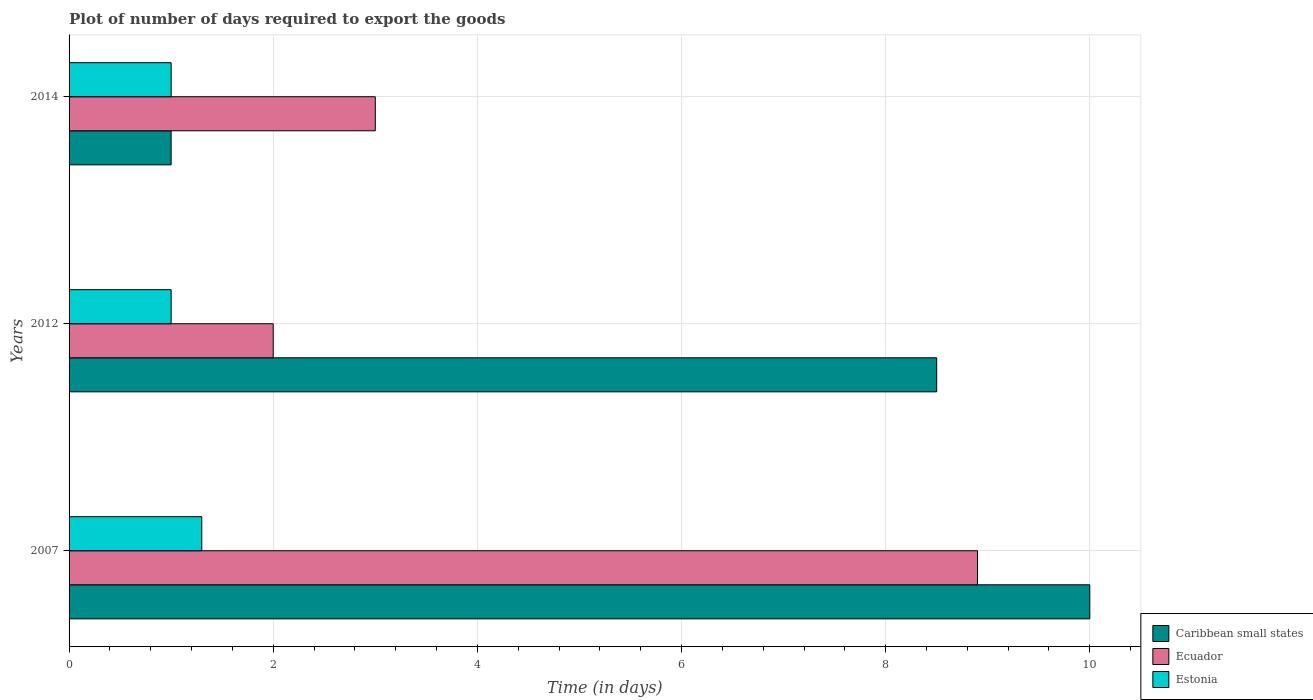Are the number of bars on each tick of the Y-axis equal?
Your response must be concise. Yes. How many bars are there on the 3rd tick from the bottom?
Make the answer very short. 3. What is the label of the 2nd group of bars from the top?
Offer a very short reply. 2012. In how many cases, is the number of bars for a given year not equal to the number of legend labels?
Your response must be concise. 0. Across all years, what is the maximum time required to export goods in Ecuador?
Make the answer very short. 8.9. In which year was the time required to export goods in Ecuador maximum?
Ensure brevity in your answer.  2007. What is the average time required to export goods in Caribbean small states per year?
Give a very brief answer. 6.5. In the year 2007, what is the difference between the time required to export goods in Caribbean small states and time required to export goods in Ecuador?
Offer a terse response. 1.1. In how many years, is the time required to export goods in Estonia greater than 3.6 days?
Provide a succinct answer. 0. What is the ratio of the time required to export goods in Caribbean small states in 2007 to that in 2012?
Your response must be concise. 1.18. Is the difference between the time required to export goods in Caribbean small states in 2007 and 2012 greater than the difference between the time required to export goods in Ecuador in 2007 and 2012?
Your answer should be very brief. No. What is the difference between the highest and the second highest time required to export goods in Ecuador?
Your response must be concise. 5.9. What is the difference between the highest and the lowest time required to export goods in Estonia?
Offer a very short reply. 0.3. In how many years, is the time required to export goods in Caribbean small states greater than the average time required to export goods in Caribbean small states taken over all years?
Give a very brief answer. 2. What does the 1st bar from the top in 2012 represents?
Ensure brevity in your answer.  Estonia. What does the 1st bar from the bottom in 2007 represents?
Offer a very short reply. Caribbean small states. How many bars are there?
Ensure brevity in your answer.  9. Are all the bars in the graph horizontal?
Your answer should be compact. Yes. What is the difference between two consecutive major ticks on the X-axis?
Your response must be concise. 2. Are the values on the major ticks of X-axis written in scientific E-notation?
Your answer should be very brief. No. Does the graph contain any zero values?
Keep it short and to the point. No. Does the graph contain grids?
Make the answer very short. Yes. How many legend labels are there?
Provide a succinct answer. 3. How are the legend labels stacked?
Keep it short and to the point. Vertical. What is the title of the graph?
Your response must be concise. Plot of number of days required to export the goods. Does "Panama" appear as one of the legend labels in the graph?
Ensure brevity in your answer.  No. What is the label or title of the X-axis?
Give a very brief answer. Time (in days). What is the label or title of the Y-axis?
Provide a succinct answer. Years. What is the Time (in days) in Caribbean small states in 2007?
Give a very brief answer. 10. What is the Time (in days) of Ecuador in 2007?
Give a very brief answer. 8.9. What is the Time (in days) of Ecuador in 2014?
Offer a terse response. 3. What is the Time (in days) in Estonia in 2014?
Provide a succinct answer. 1. Across all years, what is the maximum Time (in days) in Caribbean small states?
Make the answer very short. 10. Across all years, what is the minimum Time (in days) of Caribbean small states?
Make the answer very short. 1. Across all years, what is the minimum Time (in days) of Ecuador?
Offer a terse response. 2. Across all years, what is the minimum Time (in days) of Estonia?
Offer a very short reply. 1. What is the total Time (in days) of Caribbean small states in the graph?
Ensure brevity in your answer.  19.5. What is the difference between the Time (in days) in Caribbean small states in 2007 and that in 2012?
Your response must be concise. 1.5. What is the difference between the Time (in days) of Estonia in 2007 and that in 2012?
Provide a succinct answer. 0.3. What is the difference between the Time (in days) of Caribbean small states in 2007 and that in 2014?
Your response must be concise. 9. What is the difference between the Time (in days) of Ecuador in 2007 and that in 2014?
Provide a short and direct response. 5.9. What is the difference between the Time (in days) in Estonia in 2007 and that in 2014?
Give a very brief answer. 0.3. What is the difference between the Time (in days) in Caribbean small states in 2012 and that in 2014?
Keep it short and to the point. 7.5. What is the difference between the Time (in days) of Caribbean small states in 2007 and the Time (in days) of Estonia in 2012?
Ensure brevity in your answer.  9. What is the difference between the Time (in days) of Caribbean small states in 2007 and the Time (in days) of Ecuador in 2014?
Make the answer very short. 7. What is the difference between the Time (in days) in Ecuador in 2007 and the Time (in days) in Estonia in 2014?
Your answer should be compact. 7.9. What is the difference between the Time (in days) in Caribbean small states in 2012 and the Time (in days) in Estonia in 2014?
Provide a short and direct response. 7.5. What is the difference between the Time (in days) in Ecuador in 2012 and the Time (in days) in Estonia in 2014?
Provide a short and direct response. 1. What is the average Time (in days) in Ecuador per year?
Provide a short and direct response. 4.63. What is the average Time (in days) in Estonia per year?
Provide a succinct answer. 1.1. In the year 2007, what is the difference between the Time (in days) in Caribbean small states and Time (in days) in Ecuador?
Offer a terse response. 1.1. In the year 2012, what is the difference between the Time (in days) of Caribbean small states and Time (in days) of Ecuador?
Give a very brief answer. 6.5. In the year 2012, what is the difference between the Time (in days) in Caribbean small states and Time (in days) in Estonia?
Your response must be concise. 7.5. In the year 2012, what is the difference between the Time (in days) of Ecuador and Time (in days) of Estonia?
Provide a succinct answer. 1. In the year 2014, what is the difference between the Time (in days) in Caribbean small states and Time (in days) in Ecuador?
Provide a succinct answer. -2. What is the ratio of the Time (in days) of Caribbean small states in 2007 to that in 2012?
Your response must be concise. 1.18. What is the ratio of the Time (in days) of Ecuador in 2007 to that in 2012?
Give a very brief answer. 4.45. What is the ratio of the Time (in days) of Estonia in 2007 to that in 2012?
Your answer should be compact. 1.3. What is the ratio of the Time (in days) of Caribbean small states in 2007 to that in 2014?
Your answer should be very brief. 10. What is the ratio of the Time (in days) in Ecuador in 2007 to that in 2014?
Ensure brevity in your answer.  2.97. What is the difference between the highest and the second highest Time (in days) of Caribbean small states?
Ensure brevity in your answer.  1.5. What is the difference between the highest and the second highest Time (in days) in Estonia?
Make the answer very short. 0.3. What is the difference between the highest and the lowest Time (in days) in Ecuador?
Give a very brief answer. 6.9. What is the difference between the highest and the lowest Time (in days) in Estonia?
Your response must be concise. 0.3. 